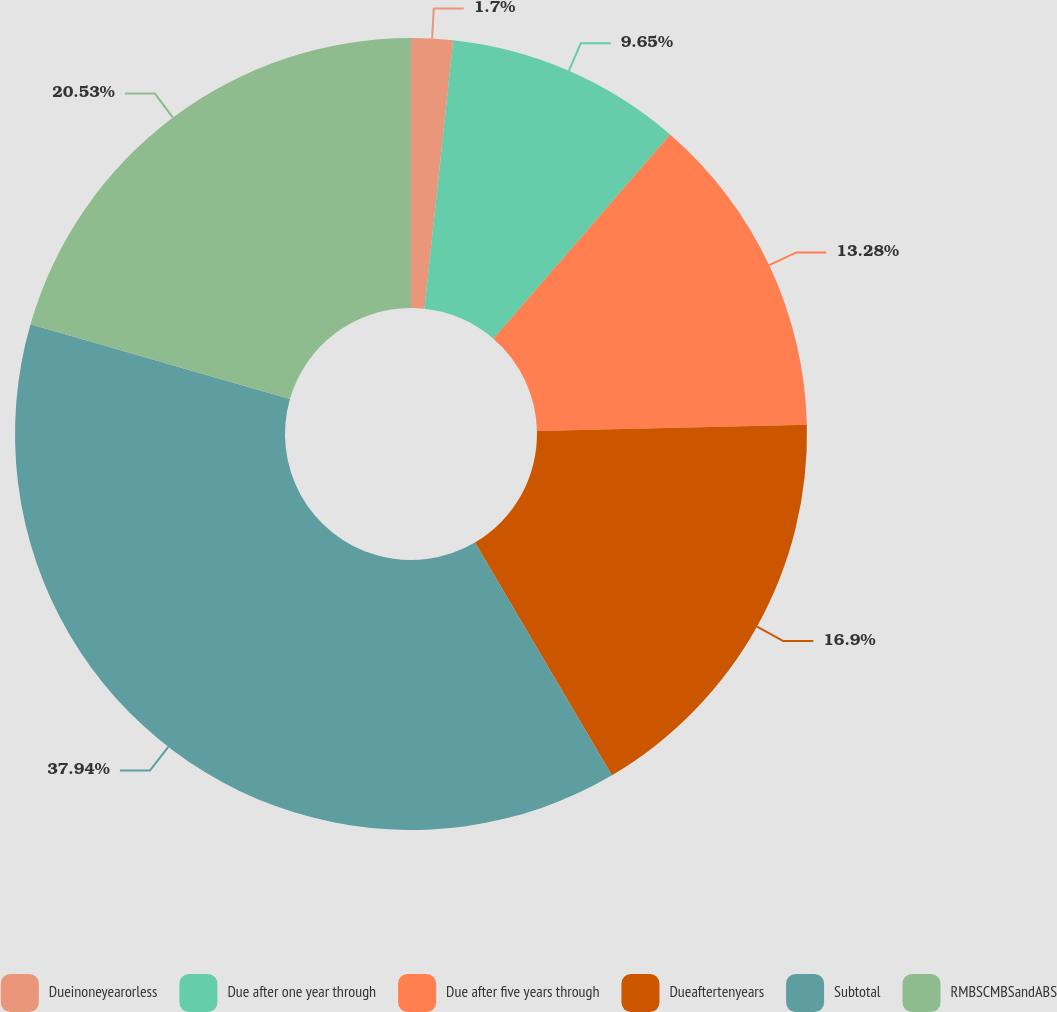<chart> <loc_0><loc_0><loc_500><loc_500><pie_chart><fcel>Dueinoneyearorless<fcel>Due after one year through<fcel>Due after five years through<fcel>Dueaftertenyears<fcel>Subtotal<fcel>RMBSCMBSandABS<nl><fcel>1.7%<fcel>9.65%<fcel>13.28%<fcel>16.9%<fcel>37.94%<fcel>20.53%<nl></chart> 